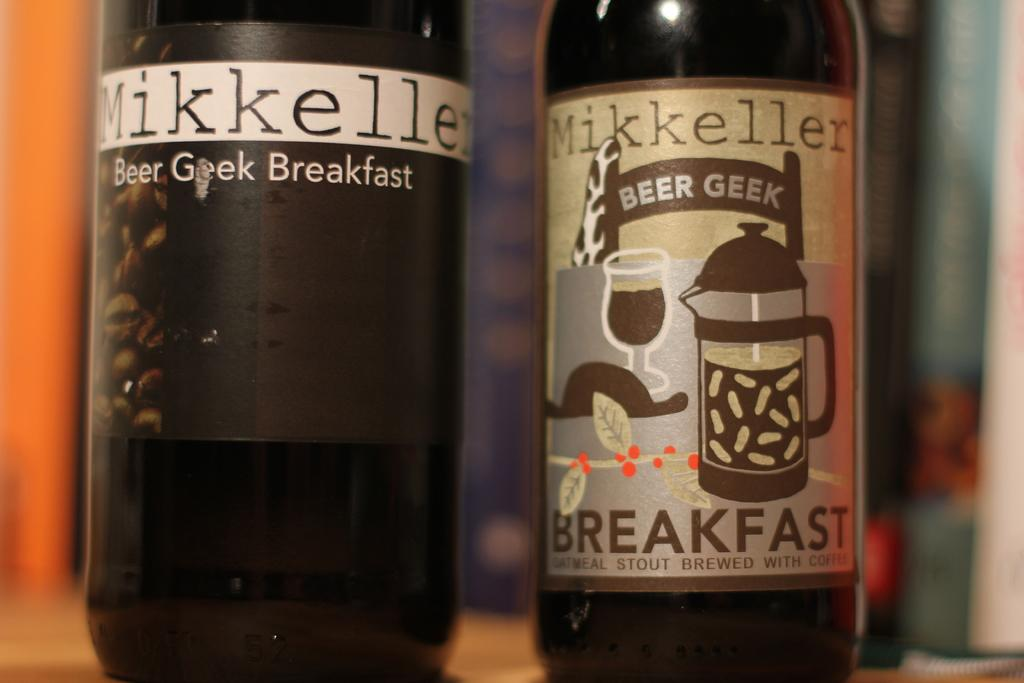<image>
Summarize the visual content of the image. Two beer bottles side by side that are from the Mikkeller Beer Geek Breakfast company. 